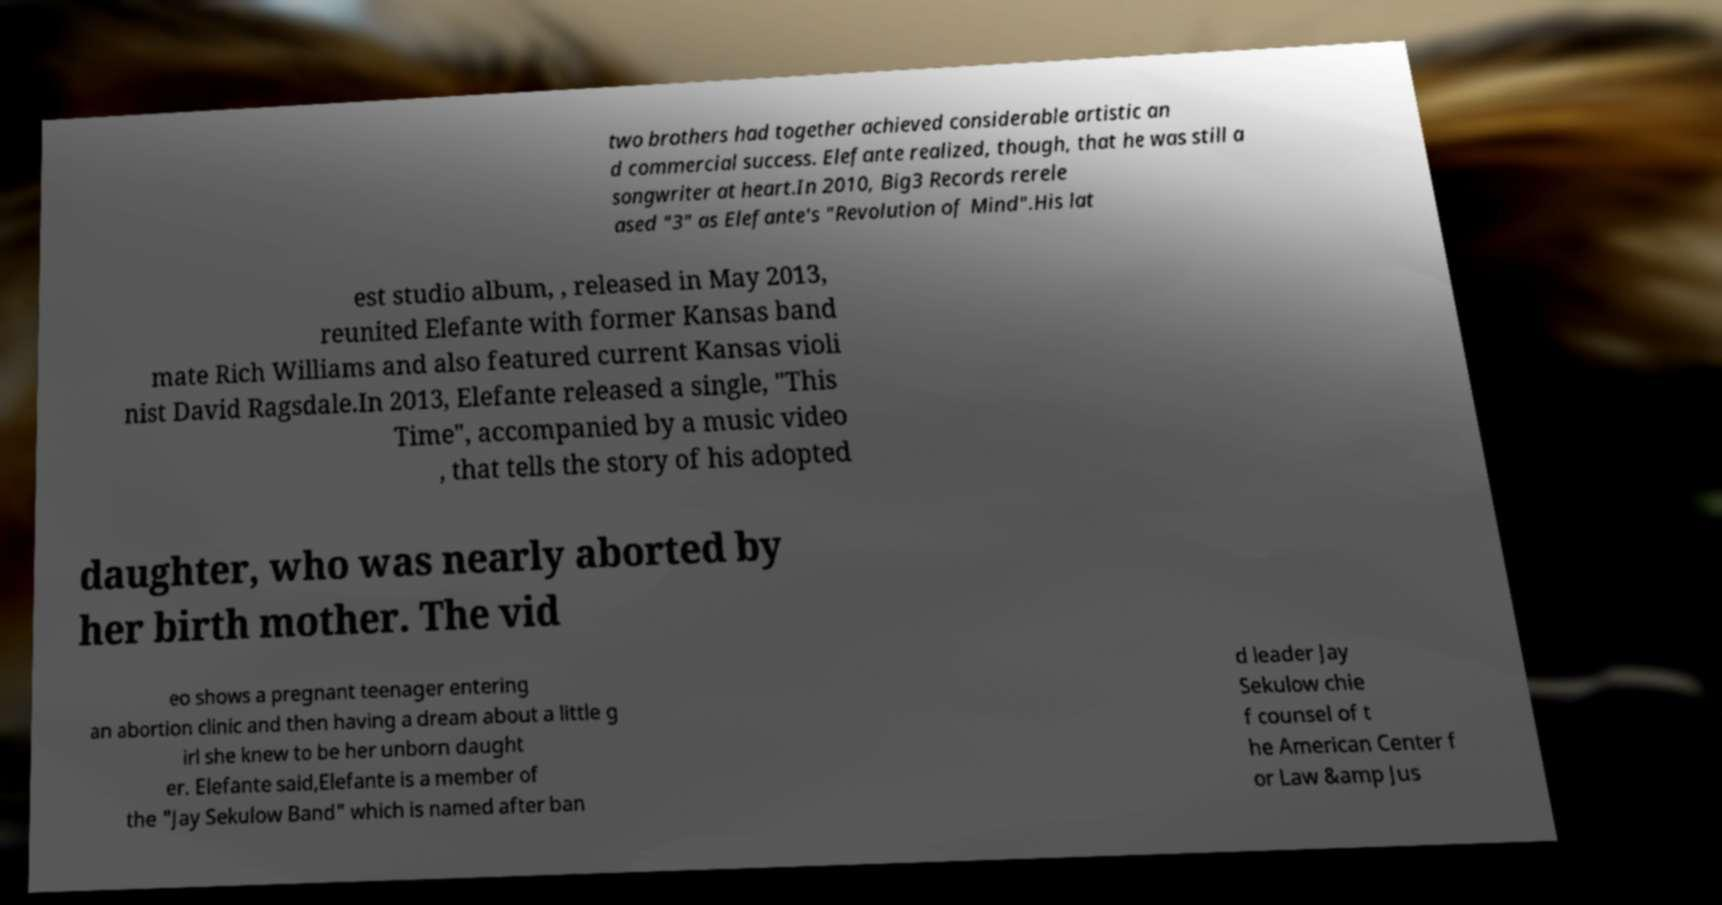There's text embedded in this image that I need extracted. Can you transcribe it verbatim? two brothers had together achieved considerable artistic an d commercial success. Elefante realized, though, that he was still a songwriter at heart.In 2010, Big3 Records rerele ased "3" as Elefante's "Revolution of Mind".His lat est studio album, , released in May 2013, reunited Elefante with former Kansas band mate Rich Williams and also featured current Kansas violi nist David Ragsdale.In 2013, Elefante released a single, "This Time", accompanied by a music video , that tells the story of his adopted daughter, who was nearly aborted by her birth mother. The vid eo shows a pregnant teenager entering an abortion clinic and then having a dream about a little g irl she knew to be her unborn daught er. Elefante said,Elefante is a member of the "Jay Sekulow Band" which is named after ban d leader Jay Sekulow chie f counsel of t he American Center f or Law &amp Jus 